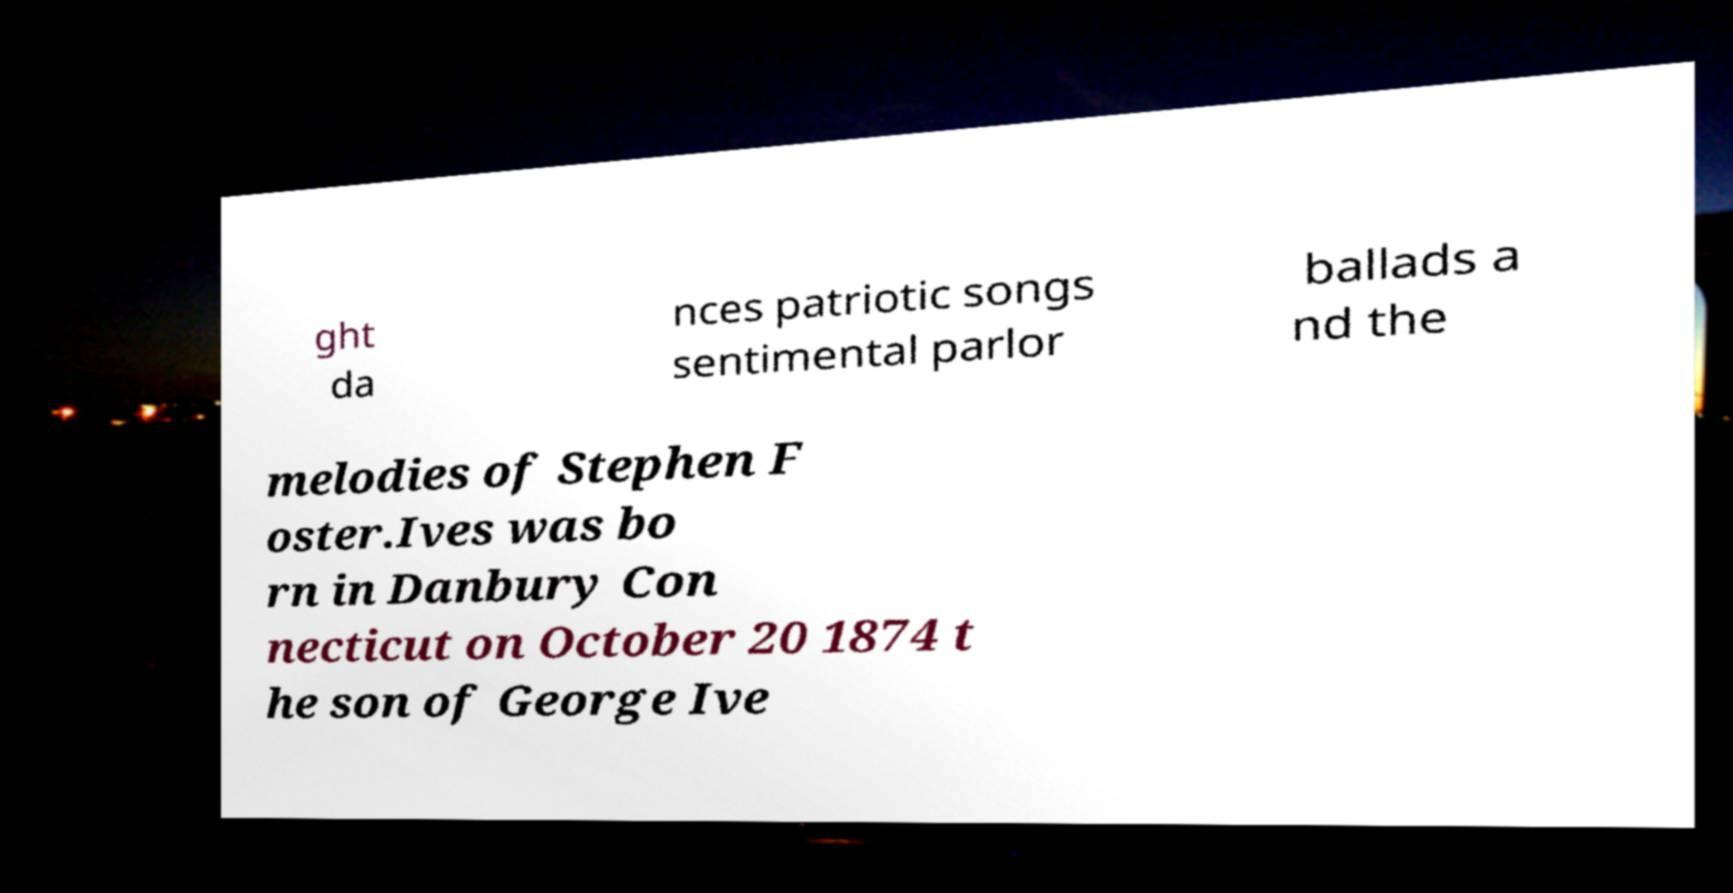Can you read and provide the text displayed in the image?This photo seems to have some interesting text. Can you extract and type it out for me? ght da nces patriotic songs sentimental parlor ballads a nd the melodies of Stephen F oster.Ives was bo rn in Danbury Con necticut on October 20 1874 t he son of George Ive 